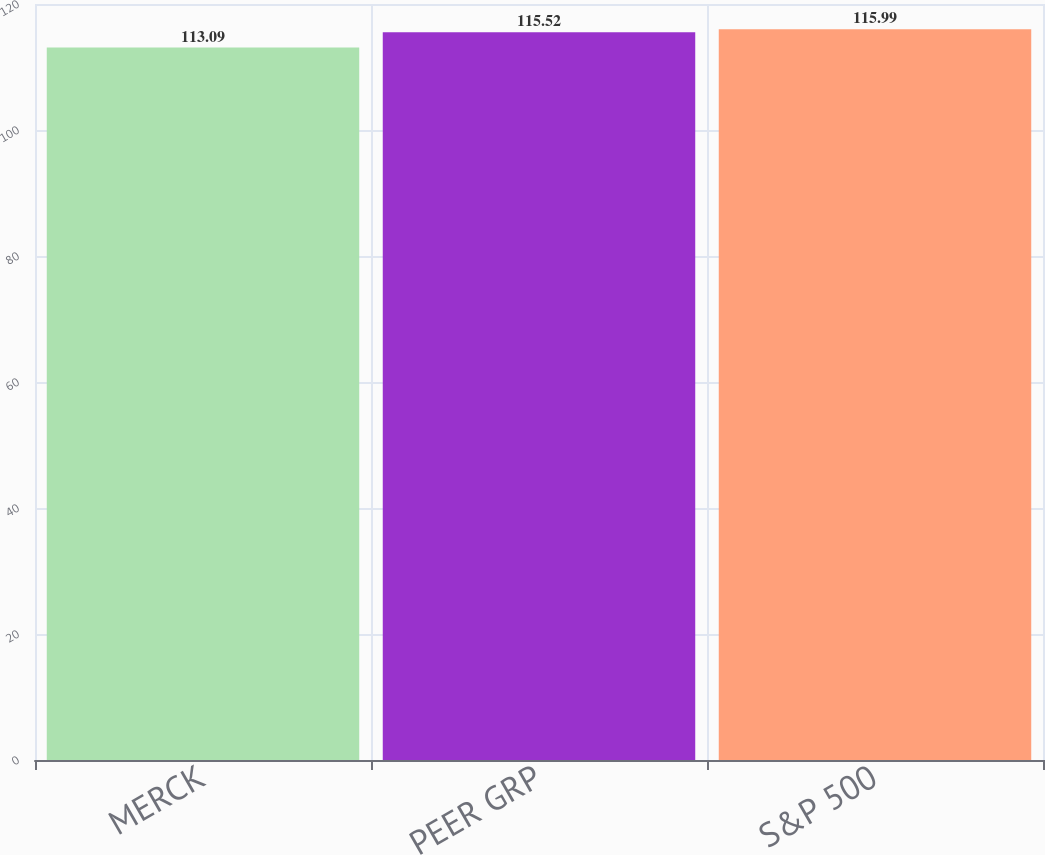Convert chart. <chart><loc_0><loc_0><loc_500><loc_500><bar_chart><fcel>MERCK<fcel>PEER GRP<fcel>S&P 500<nl><fcel>113.09<fcel>115.52<fcel>115.99<nl></chart> 